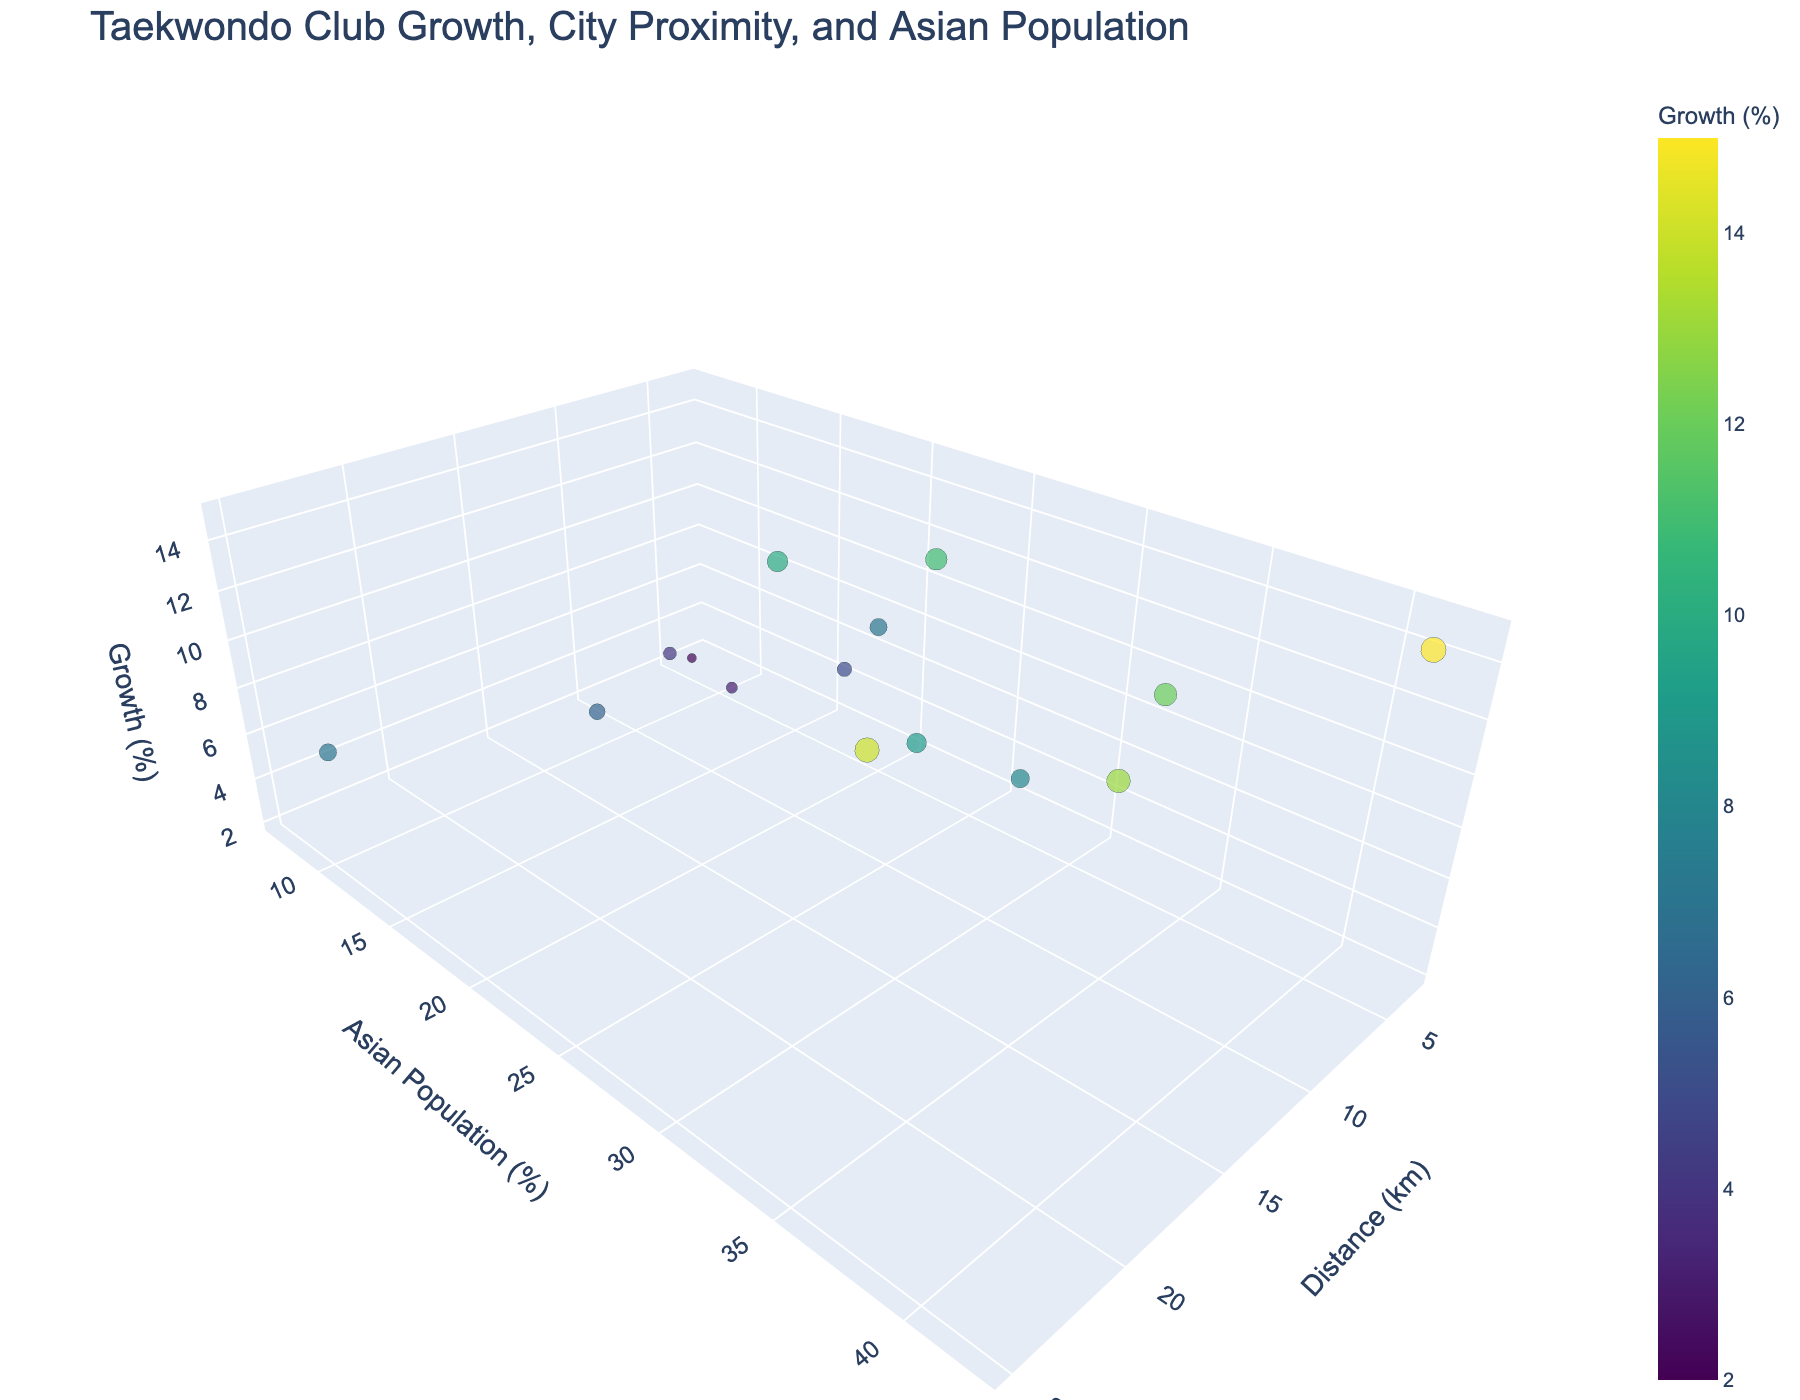How many Taekwondo clubs are represented in the plot? Count the number of unique data points (markers) representing Taekwondo clubs in the 3D scatter plot.
Answer: 15 Which Taekwondo club has the highest membership growth? Identify the data point with the highest value on the "Membership Growth (%)" axis and find the corresponding club name from the hover information.
Answer: Vancouver Taekwondo Academy What is the relationship between membership growth and distance from major cities? Observe the trend of the data points along the distance and membership growth axes. Generally, see if higher or lower membership growth is associated with proximity to major cities.
Answer: Closer distance tends to correlate with higher growth Which club is furthest from a major city and what is its membership growth percentage? Find the data point with the highest value on the "Distance from Major City (km)" axis, then use the hover information to get the Club Name and Membership Growth (%) of that point.
Answer: London Olympic TKD, 7% Identify the club with the highest Asian population percentage and provide its membership growth and distance from a major city. Locate the data point with the highest value on the "Asian Population (%)" axis and use hover information to extract the corresponding membership growth and distance from a major city data.
Answer: Vancouver Taekwondo Academy, 15%, 5 km How does the membership growth of Mississauga Grandmaster Park's compare with Edmonton Tiger Taekwondo? Find and compare the two clubs' data points in terms of their "Membership Growth (%)" values by using the hover information.
Answer: Mississauga Grandmaster Park's has a higher membership growth (14%) compared to Edmonton Tiger Taekwondo (8%) On average, do clubs with a higher Asian population percentage have higher membership growth? Visually group data points with higher Asian population percentages and compare their membership growth to those with lower Asian population percentages to estimate any general trend or correlation.
Answer: Yes, higher Asian population tends to correlate with higher growth Which club has the smallest membership growth, and how far is it from a major city? Identify the data point with the lowest value on the "Membership Growth (%)" axis, then use hover information to find the corresponding club name and distance from a major city.
Answer: Halifax Hwa-Rang Do, 4 km What is the general trend of membership growth with respect to both distance from major cities and Asian population percentage? Analyze the overall distribution and direction of data points across all three axes, identifying any patterns or trends in how membership growth changes with varying distances and Asian population percentages.
Answer: Growth tends to be higher with closer proximity to major cities and higher Asian population percentages Which club has the second-highest membership growth and what is the Asian population percentage in its locale? Identify the data point with the second-highest value on the "Membership Growth (%)" axis, then use hover information to get the corresponding Asian population percentage.
Answer: Mississauga Grandmaster Park's, 33% 